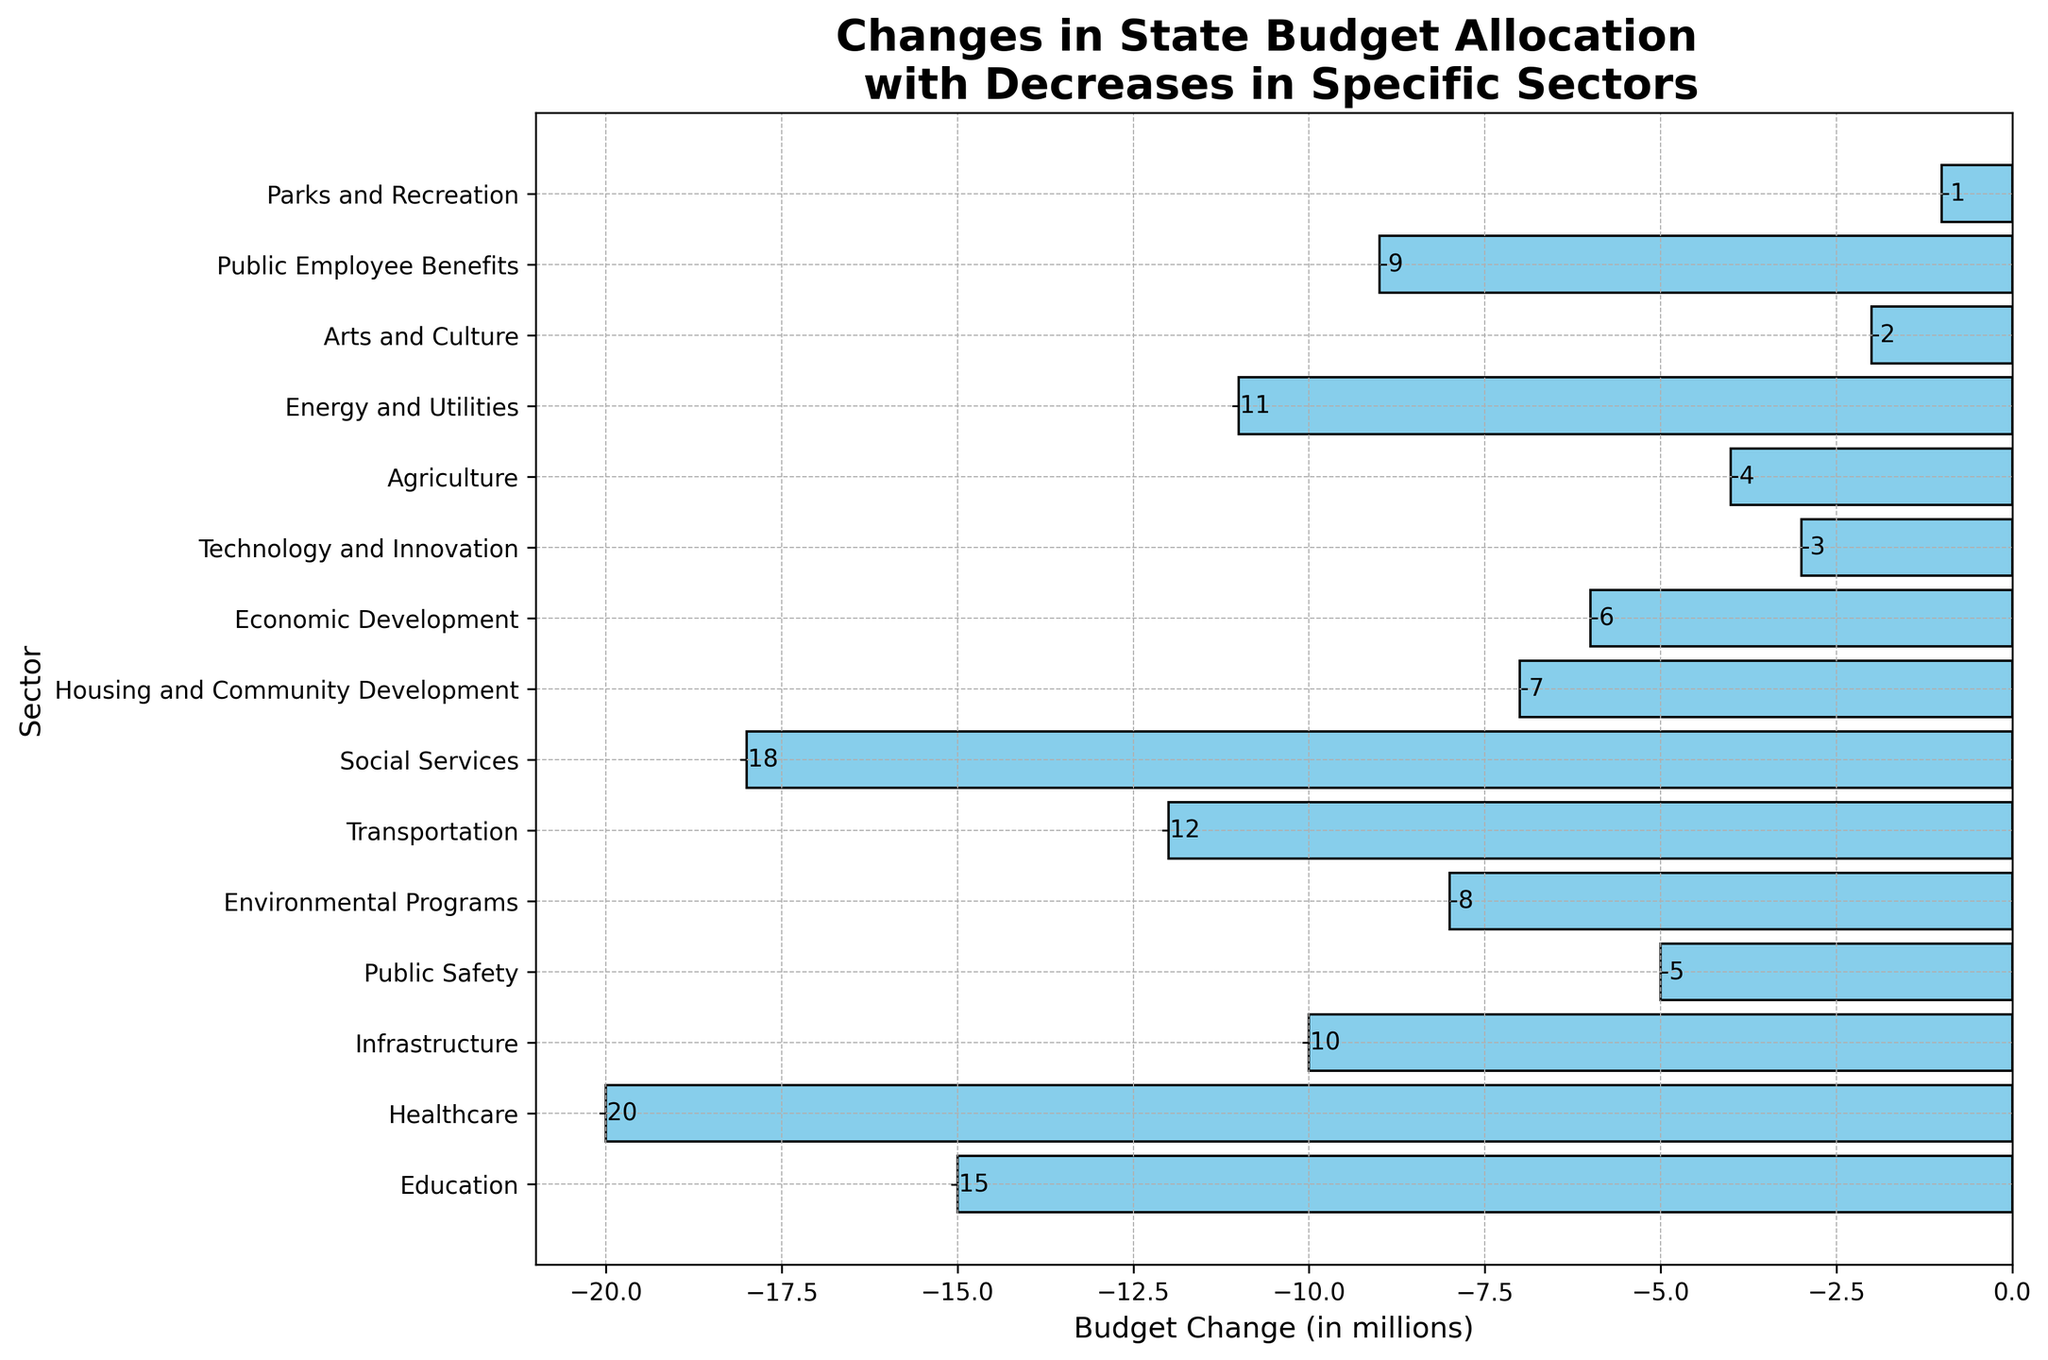Which sector has the largest decrease in budget allocation? The bar representing 'Healthcare' is the longest among all sectors and, based on the x-axis labels, indicates a budget change of -20 million.
Answer: Healthcare Which three sectors have the least budget decrease? The shortest bars represent 'Parks and Recreation', 'Arts and Culture', and 'Technology and Innovation' with budget changes of -1, -2, and -3 million respectively.
Answer: Parks and Recreation, Arts and Culture, Technology and Innovation What is the total budget decrease for Education, Public Safety, and Housing and Community Development combined? The budget changes for 'Education', 'Public Safety', and 'Housing and Community Development' are -15, -5, and -7 million respectively. Summing these: -15 + -5 + -7 = -27 million.
Answer: -27 million How does the budget decrease for Social Services compare to that of Transportation? The budget decrease for 'Social Services' is -18 million, whereas for 'Transportation' it is -12 million. Social Services has a larger budget decrease than Transportation.
Answer: Social Services has a larger budget decrease Which sector has a budget decrease that is exactly half of the decrease in Healthcare? Healthcare has a budget decrease of -20 million. The sector with a decrease of -10 million, which is half of -20 million, is 'Infrastructure'.
Answer: Infrastructure How many sectors have a budget decrease greater than 10 million? The sectors with budget decreases greater than 10 million are 'Healthcare' (-20), 'Social Services' (-18), 'Education' (-15), 'Transportation' (-12), and 'Energy and Utilities' (-11). There are 5 such sectors.
Answer: 5 sectors What is the average budget decrease across all sectors? Summing all the budget decreases: -15 + -20 + -10 + -5 + -8 + -12 + -18 + -7 + -6 + -3 + -4 + -11 + -2 + -9 + -1 = -131 million. There are 15 sectors. The average is -131 / 15 = -8.73 million.
Answer: -8.73 million 